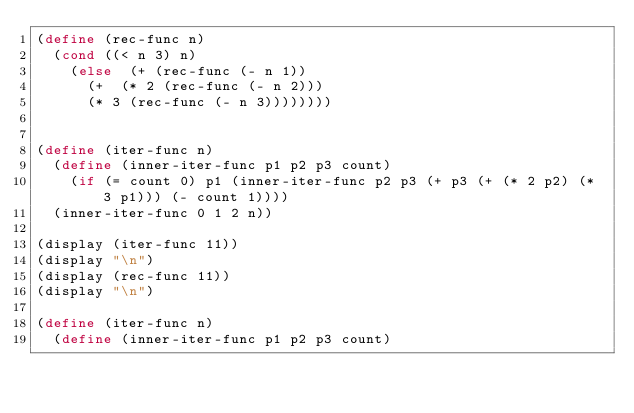<code> <loc_0><loc_0><loc_500><loc_500><_Scheme_>(define (rec-func n)
  (cond ((< n 3) n) 
    (else  (+ (rec-func (- n 1)) 
      (+  (* 2 (rec-func (- n 2))) 
      (* 3 (rec-func (- n 3))))))))


(define (iter-func n)
  (define (inner-iter-func p1 p2 p3 count)
    (if (= count 0) p1 (inner-iter-func p2 p3 (+ p3 (+ (* 2 p2) (* 3 p1))) (- count 1))))
  (inner-iter-func 0 1 2 n))

(display (iter-func 11))
(display "\n")
(display (rec-func 11))
(display "\n")

(define (iter-func n)
  (define (inner-iter-func p1 p2 p3 count)
</code> 